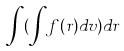<formula> <loc_0><loc_0><loc_500><loc_500>\int ( \int f ( r ) d v ) d r</formula> 